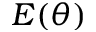Convert formula to latex. <formula><loc_0><loc_0><loc_500><loc_500>E ( \theta )</formula> 